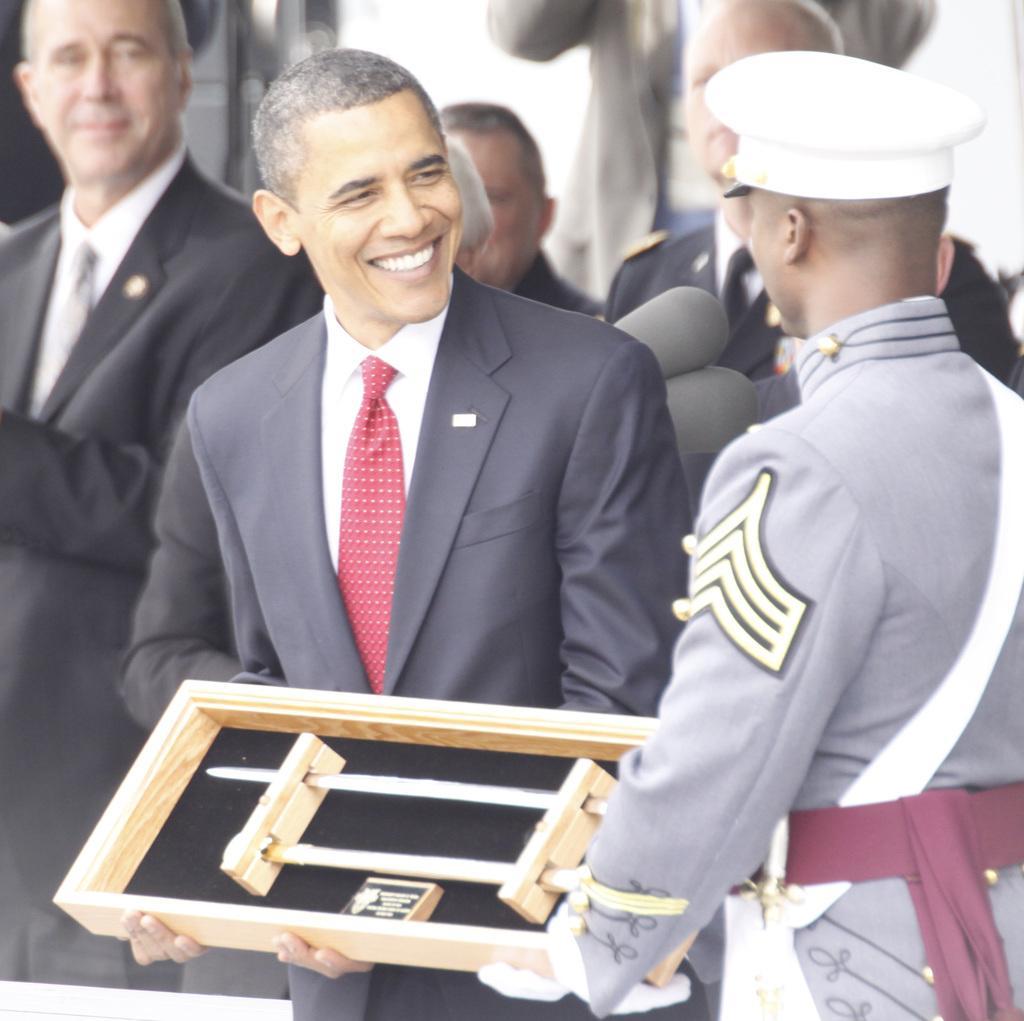In one or two sentences, can you explain what this image depicts? In this image there is a person on the left side who is presenting the wooden tray to the officer who is on the right side. In the background there are few people who are clapping their hands. 